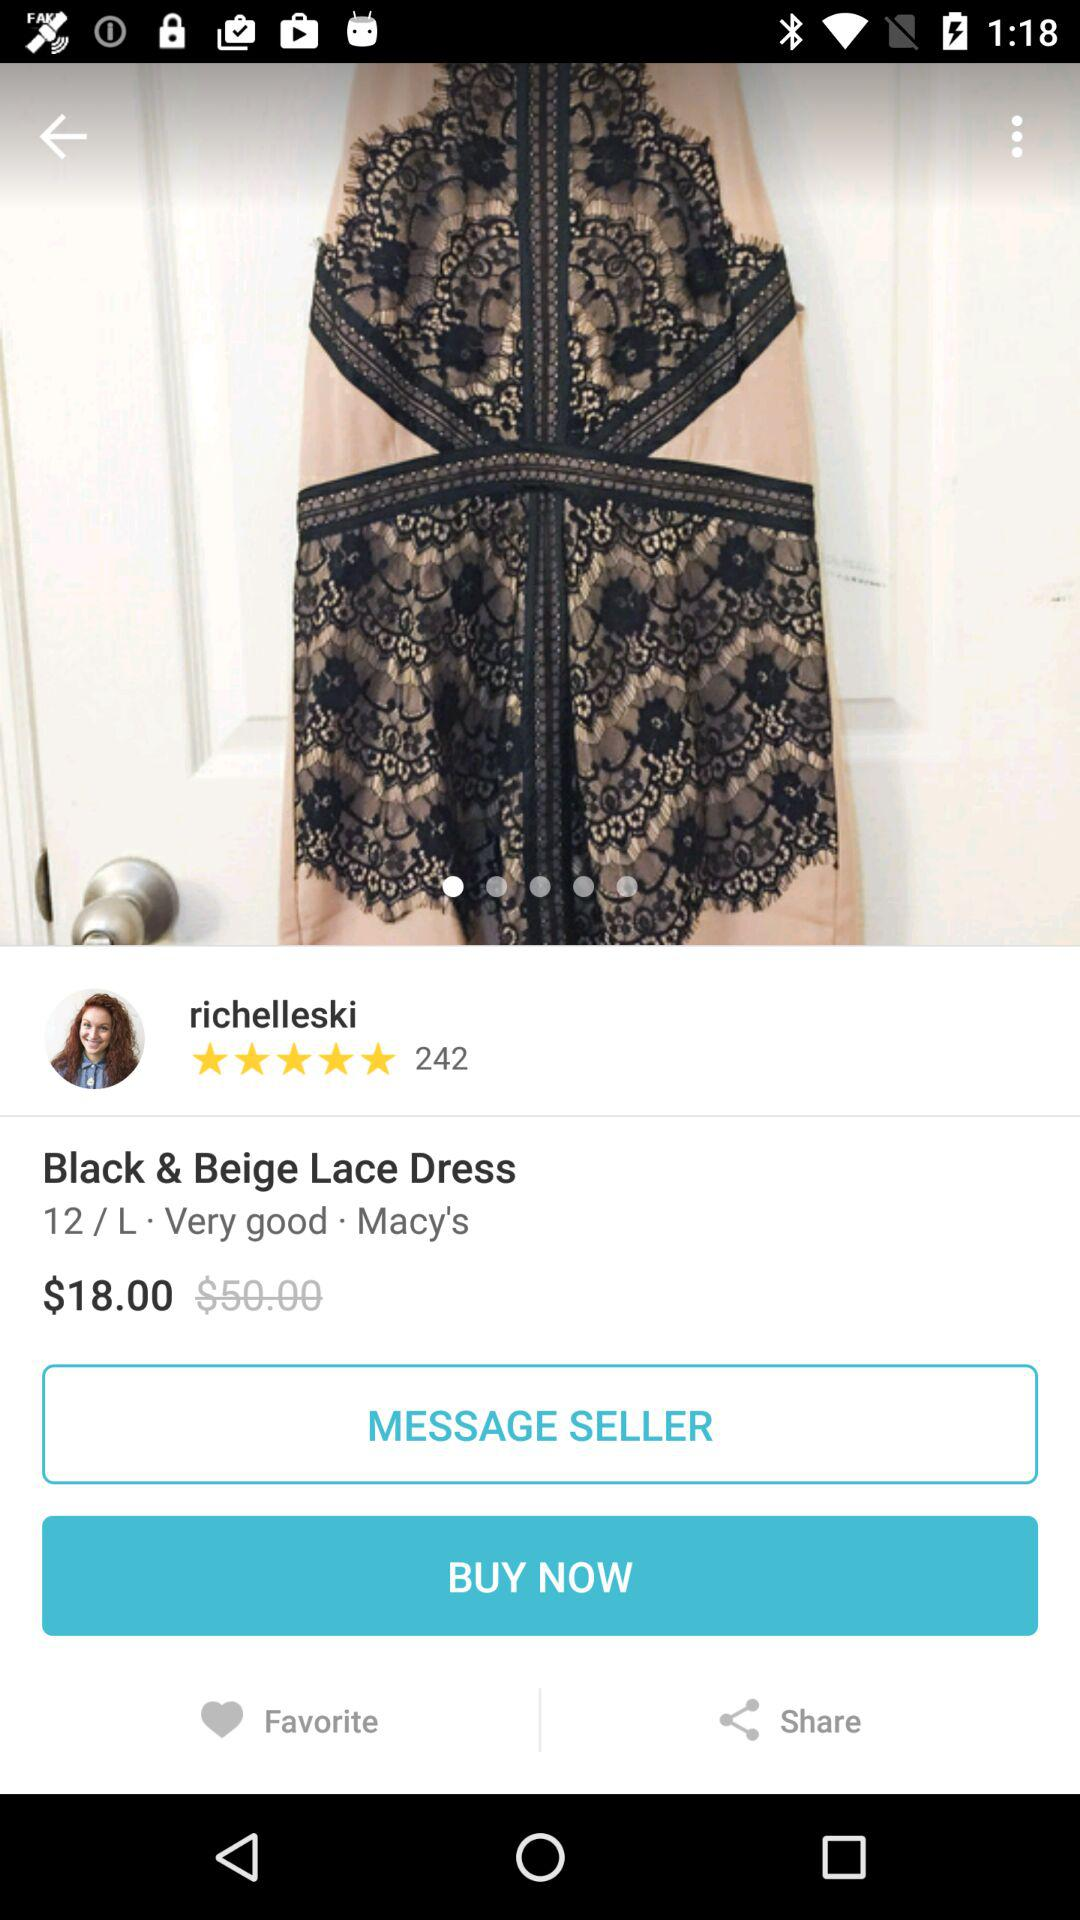Who bought the dress? The dress was bought by "richelleski". 